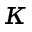<formula> <loc_0><loc_0><loc_500><loc_500>\kappa</formula> 